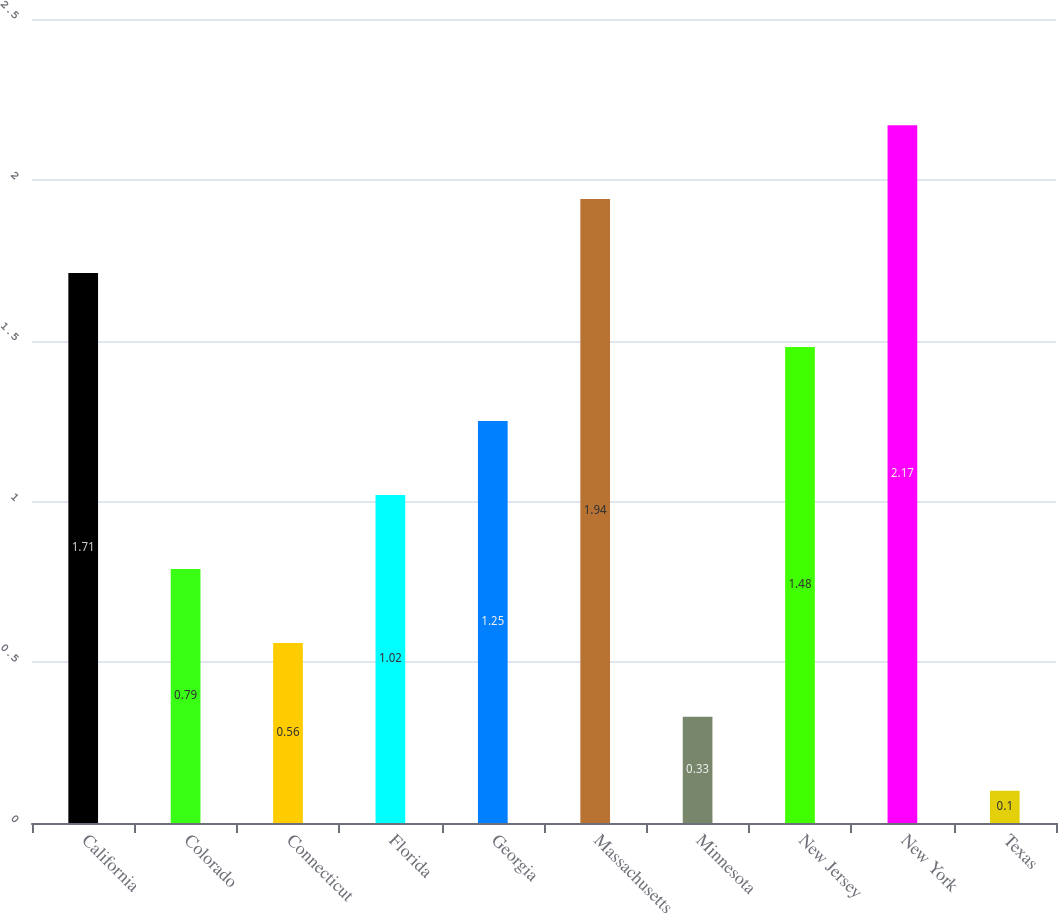Convert chart to OTSL. <chart><loc_0><loc_0><loc_500><loc_500><bar_chart><fcel>California<fcel>Colorado<fcel>Connecticut<fcel>Florida<fcel>Georgia<fcel>Massachusetts<fcel>Minnesota<fcel>New Jersey<fcel>New York<fcel>Texas<nl><fcel>1.71<fcel>0.79<fcel>0.56<fcel>1.02<fcel>1.25<fcel>1.94<fcel>0.33<fcel>1.48<fcel>2.17<fcel>0.1<nl></chart> 